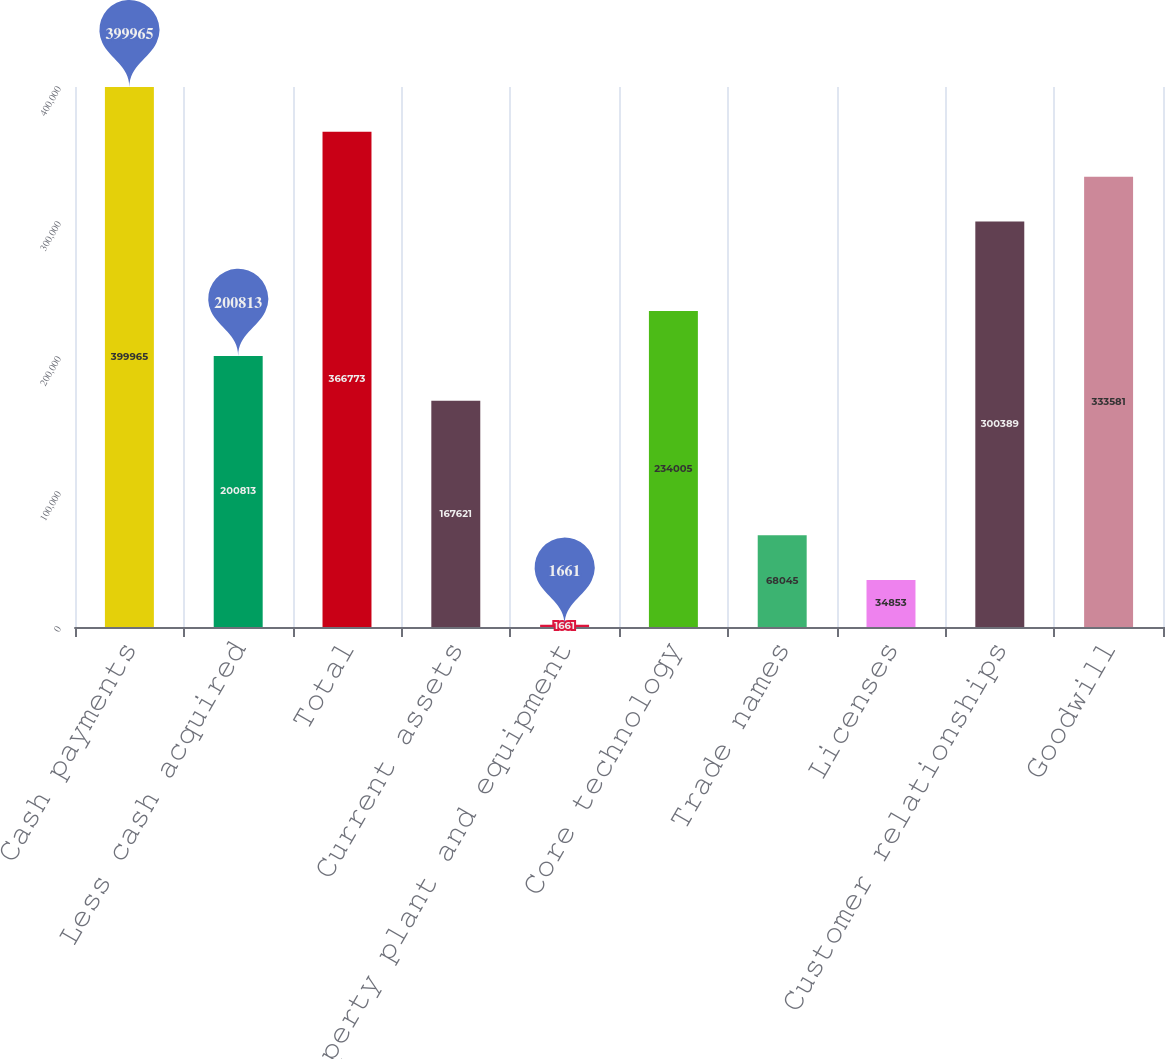Convert chart. <chart><loc_0><loc_0><loc_500><loc_500><bar_chart><fcel>Cash payments<fcel>Less cash acquired<fcel>Total<fcel>Current assets<fcel>Property plant and equipment<fcel>Core technology<fcel>Trade names<fcel>Licenses<fcel>Customer relationships<fcel>Goodwill<nl><fcel>399965<fcel>200813<fcel>366773<fcel>167621<fcel>1661<fcel>234005<fcel>68045<fcel>34853<fcel>300389<fcel>333581<nl></chart> 